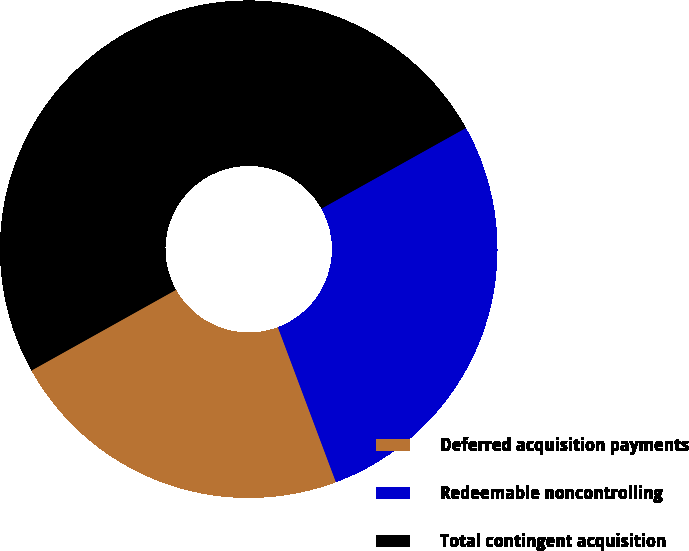Convert chart. <chart><loc_0><loc_0><loc_500><loc_500><pie_chart><fcel>Deferred acquisition payments<fcel>Redeemable noncontrolling<fcel>Total contingent acquisition<nl><fcel>22.6%<fcel>27.4%<fcel>50.0%<nl></chart> 